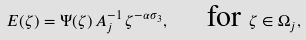Convert formula to latex. <formula><loc_0><loc_0><loc_500><loc_500>E ( \zeta ) = \Psi ( \zeta ) \, A _ { j } ^ { - 1 } \, \zeta ^ { - \alpha \sigma _ { 3 } } , \quad \text { for } \zeta \in \Omega _ { j } ,</formula> 